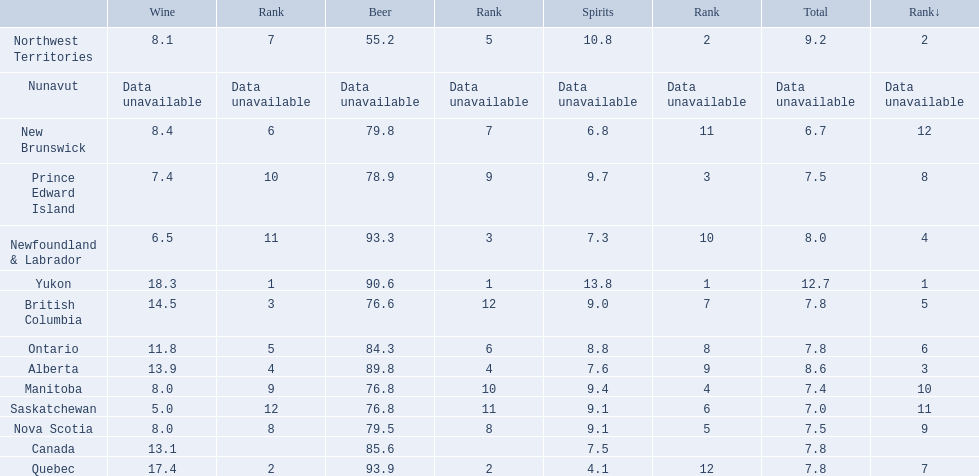Which locations consume the same total amount of alcoholic beverages as another location? British Columbia, Ontario, Quebec, Prince Edward Island, Nova Scotia. Which of these consumes more then 80 of beer? Ontario, Quebec. Of those what was the consumption of spirits of the one that consumed the most beer? 4.1. 